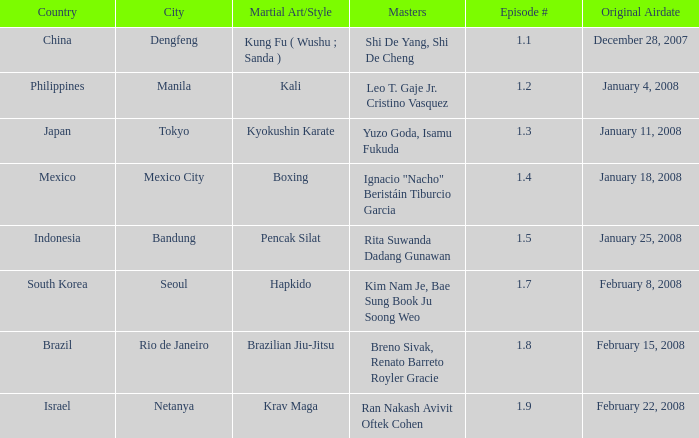Which martial arts style was shown in Rio de Janeiro? Brazilian Jiu-Jitsu. I'm looking to parse the entire table for insights. Could you assist me with that? {'header': ['Country', 'City', 'Martial Art/Style', 'Masters', 'Episode #', 'Original Airdate'], 'rows': [['China', 'Dengfeng', 'Kung Fu ( Wushu ; Sanda )', 'Shi De Yang, Shi De Cheng', '1.1', 'December 28, 2007'], ['Philippines', 'Manila', 'Kali', 'Leo T. Gaje Jr. Cristino Vasquez', '1.2', 'January 4, 2008'], ['Japan', 'Tokyo', 'Kyokushin Karate', 'Yuzo Goda, Isamu Fukuda', '1.3', 'January 11, 2008'], ['Mexico', 'Mexico City', 'Boxing', 'Ignacio "Nacho" Beristáin Tiburcio Garcia', '1.4', 'January 18, 2008'], ['Indonesia', 'Bandung', 'Pencak Silat', 'Rita Suwanda Dadang Gunawan', '1.5', 'January 25, 2008'], ['South Korea', 'Seoul', 'Hapkido', 'Kim Nam Je, Bae Sung Book Ju Soong Weo', '1.7', 'February 8, 2008'], ['Brazil', 'Rio de Janeiro', 'Brazilian Jiu-Jitsu', 'Breno Sivak, Renato Barreto Royler Gracie', '1.8', 'February 15, 2008'], ['Israel', 'Netanya', 'Krav Maga', 'Ran Nakash Avivit Oftek Cohen', '1.9', 'February 22, 2008']]} 